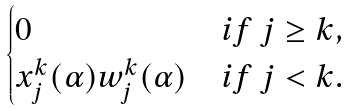<formula> <loc_0><loc_0><loc_500><loc_500>\begin{cases} 0 & i f \ j \geq k , \\ x _ { j } ^ { k } ( \alpha ) w _ { j } ^ { k } ( \alpha ) & i f \ j < k . \end{cases}</formula> 